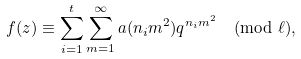<formula> <loc_0><loc_0><loc_500><loc_500>f ( z ) \equiv \sum _ { i = 1 } ^ { t } \sum _ { m = 1 } ^ { \infty } a ( n _ { i } m ^ { 2 } ) q ^ { n _ { i } m ^ { 2 } } \pmod { \ell } ,</formula> 